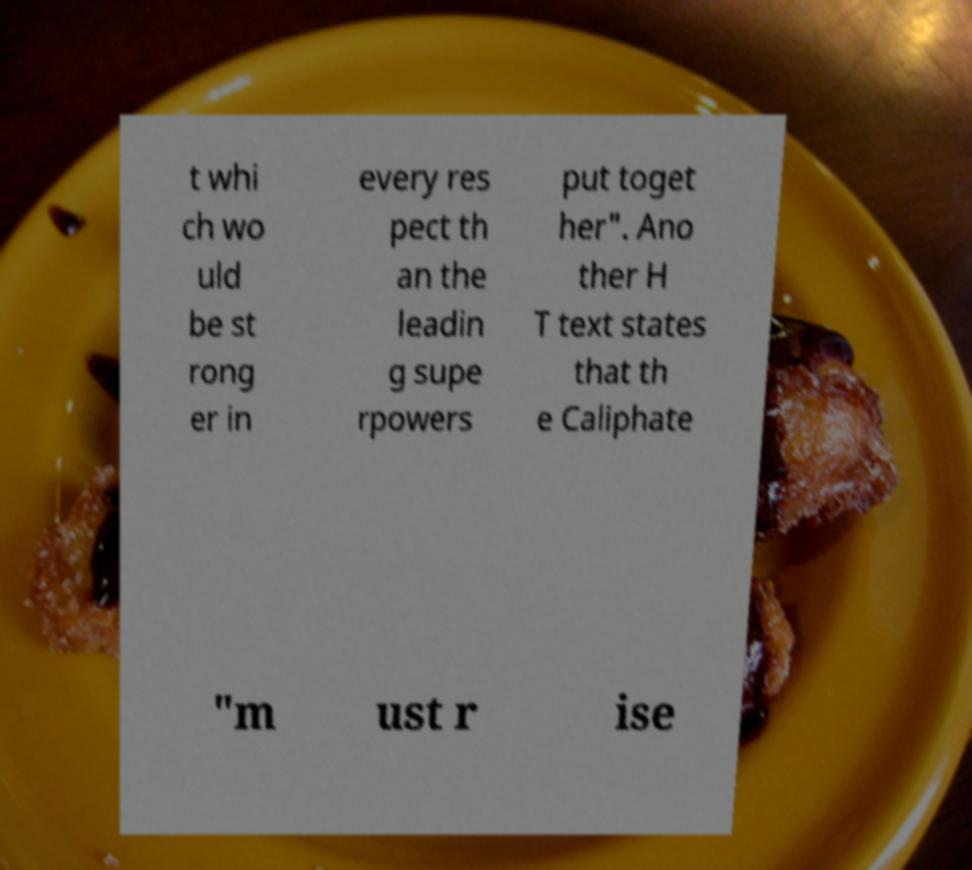Can you accurately transcribe the text from the provided image for me? t whi ch wo uld be st rong er in every res pect th an the leadin g supe rpowers put toget her". Ano ther H T text states that th e Caliphate "m ust r ise 